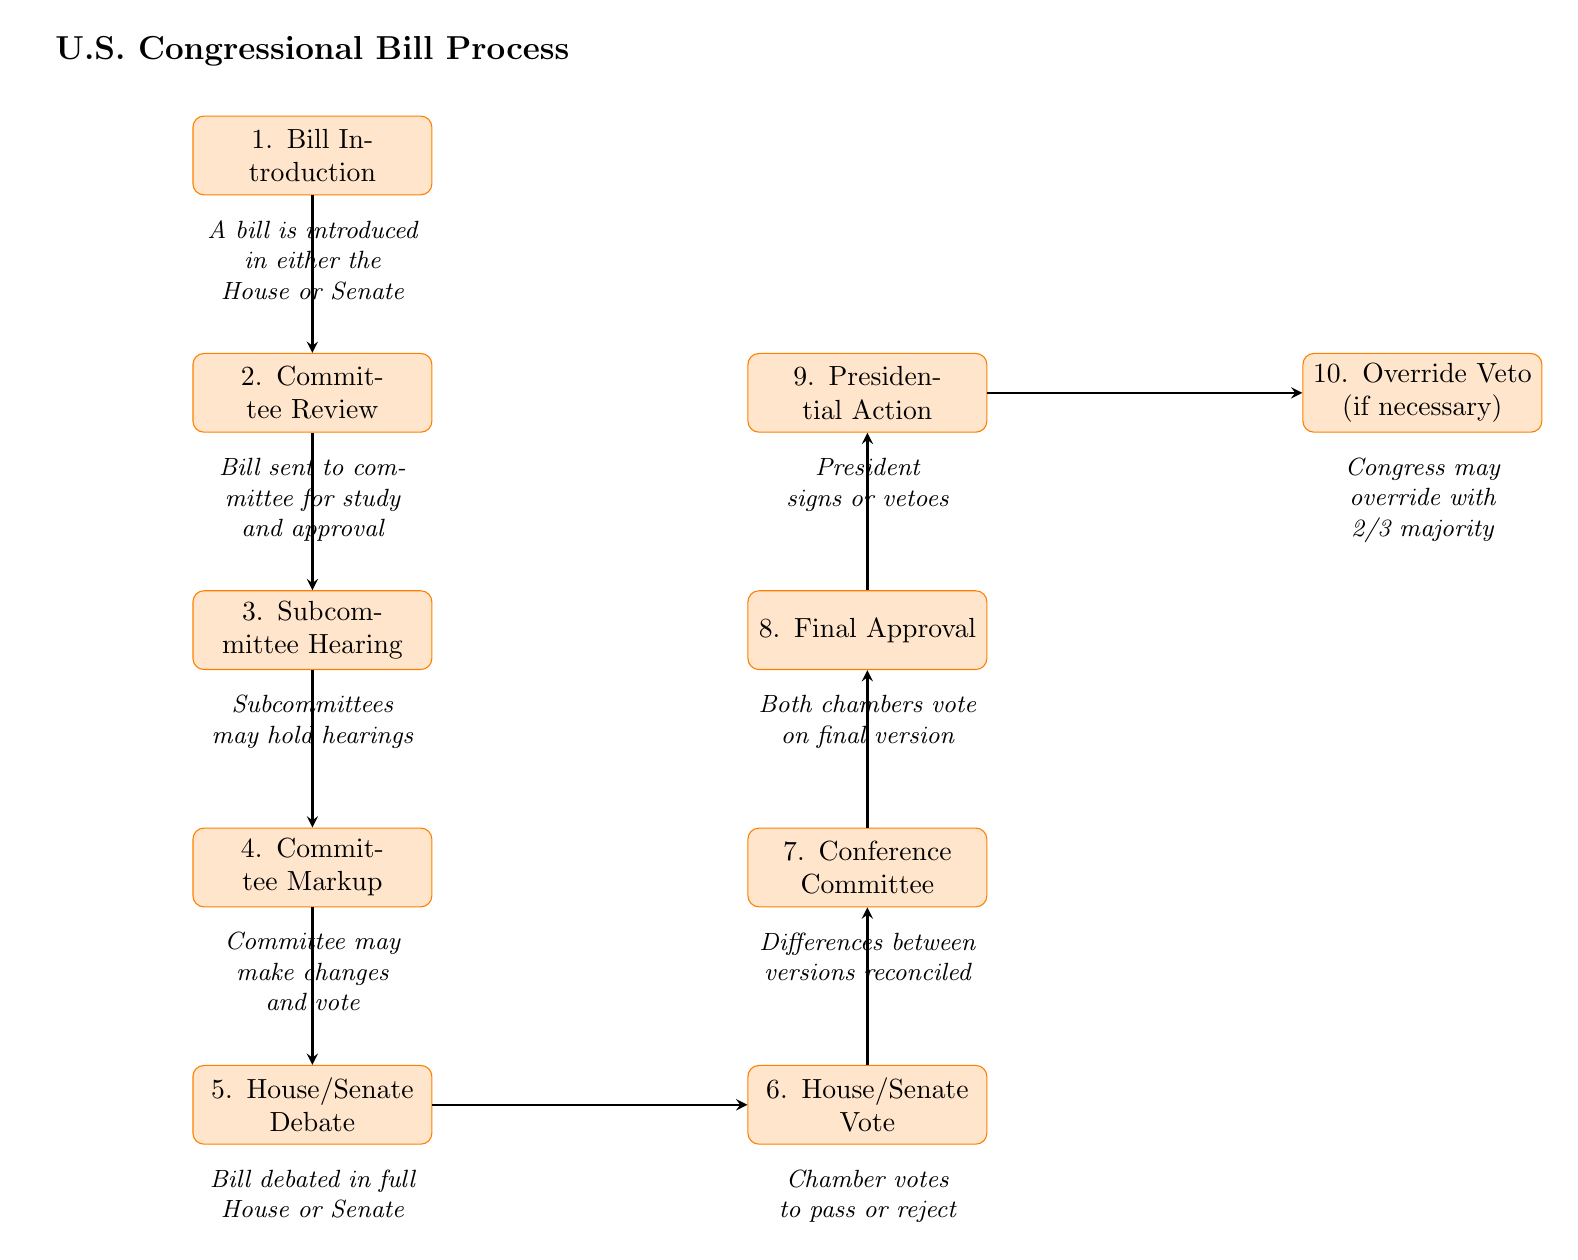What is the first step in the bill process? The first step as indicated in the diagram is "Bill Introduction". This is the starting point of the process, as depicted at the top.
Answer: Bill Introduction How many processes are involved in the bill process as per the diagram? The diagram outlines a total of ten distinct processes involved in the bill passing procedure in the U.S. Congress. Counting each individual process from "Bill Introduction" to "Override Veto (if necessary)" gives us ten.
Answer: 10 What happens after the House/Senate Debate? According to the diagram, the step that follows "House/Senate Debate" is "House/Senate Vote". This indicates the progression from debate to a formal voting process.
Answer: House/Senate Vote Which stage involves the President? The diagram shows that the stage involving the President is "Presidential Action". At this point, the President has the power to either sign the bill into law or veto it.
Answer: Presidential Action What is required to override a presidential veto? To override a presidential veto, the diagram specifies that Congress may override with a "2/3 majority". This means that a significant majority of both chambers must agree to counter the presidential decision.
Answer: 2/3 majority What is the purpose of the Conference Committee? The "Conference Committee" stage is for reconciling differences between the House and Senate versions of the bill. This step ensures both chambers agree on the same version before proceeding.
Answer: Differences reconciled Which step involves committee revisions to the bill? The process that includes committee revisions is "Committee Markup". This is where the committee can make changes to the bill before it is progressed further.
Answer: Committee Markup What occurs during the Subcommittee Hearing? In the "Subcommittee Hearing" step, as indicated in the diagram, subcommittees may hold hearings to discuss and gather information on the bill being considered.
Answer: Hearings held What is the final step of the process? The last step in the diagram is "Override Veto (if necessary)", which occurs only if a veto has been issued and a congressional override is attempted.
Answer: Override Veto (if necessary) 